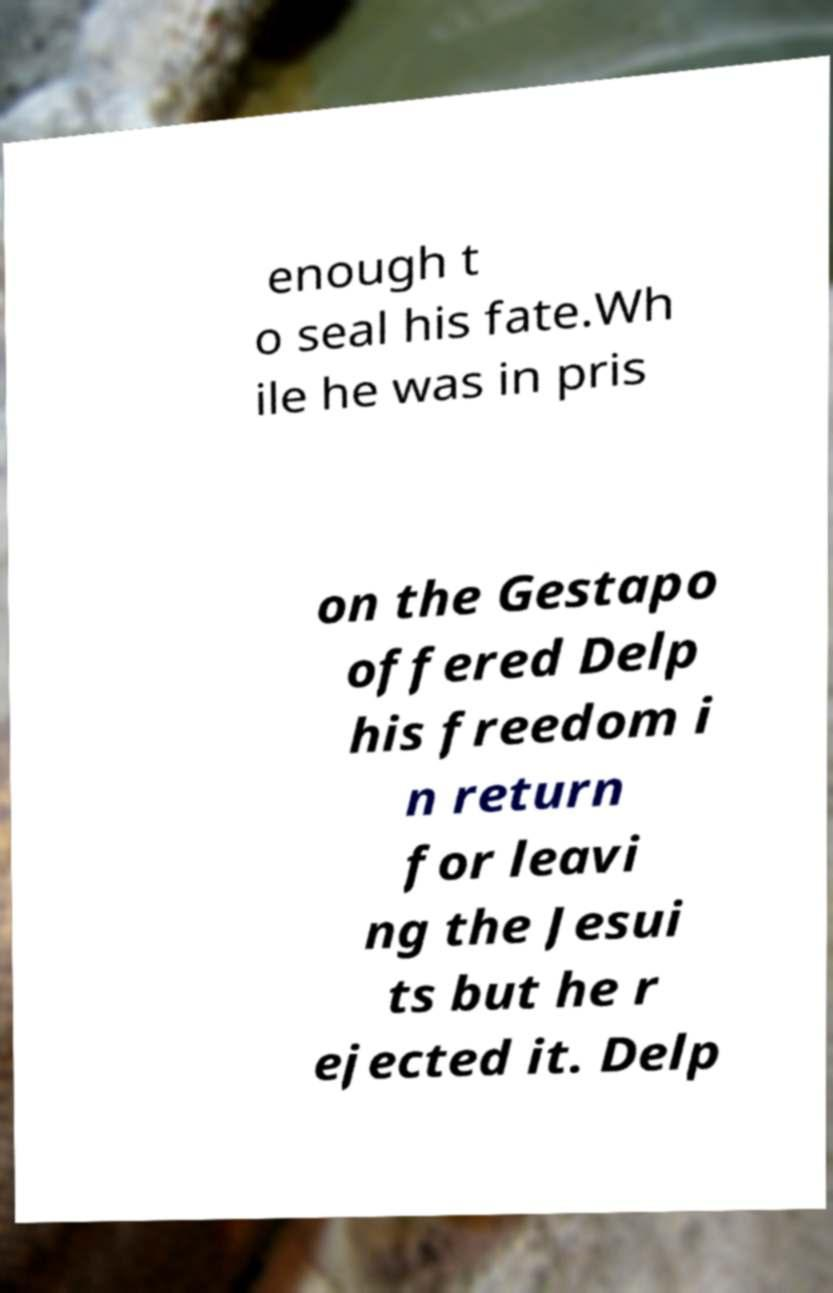Could you extract and type out the text from this image? enough t o seal his fate.Wh ile he was in pris on the Gestapo offered Delp his freedom i n return for leavi ng the Jesui ts but he r ejected it. Delp 